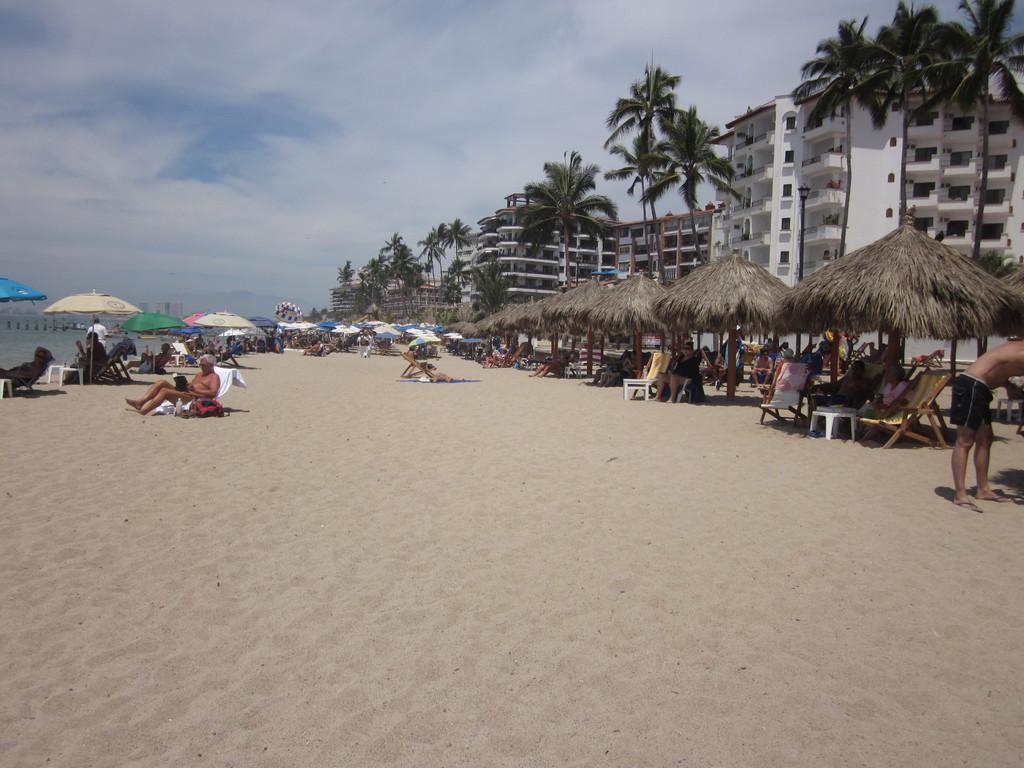Describe this image in one or two sentences. In this image there is the sky, there are clouds in the sky, there is a sea truncated towards the left of the image, there are umbrellas, there is an umbrella truncated towards the left of the image, there are persons sitting, there are chairs, there are trees, there are buildings, there is a tree truncated towards the right of the image, there is a building truncated towards the left of the image, there is sand, there is a person truncated towards the right of the image. 